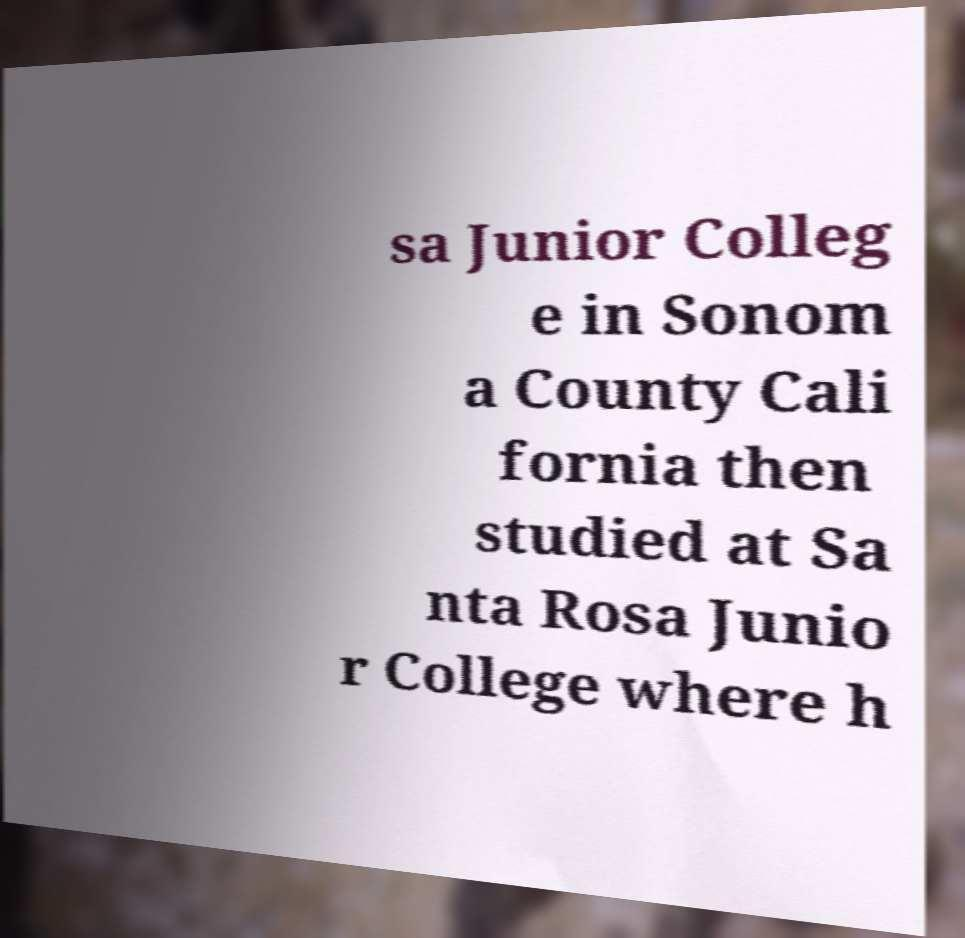I need the written content from this picture converted into text. Can you do that? sa Junior Colleg e in Sonom a County Cali fornia then studied at Sa nta Rosa Junio r College where h 